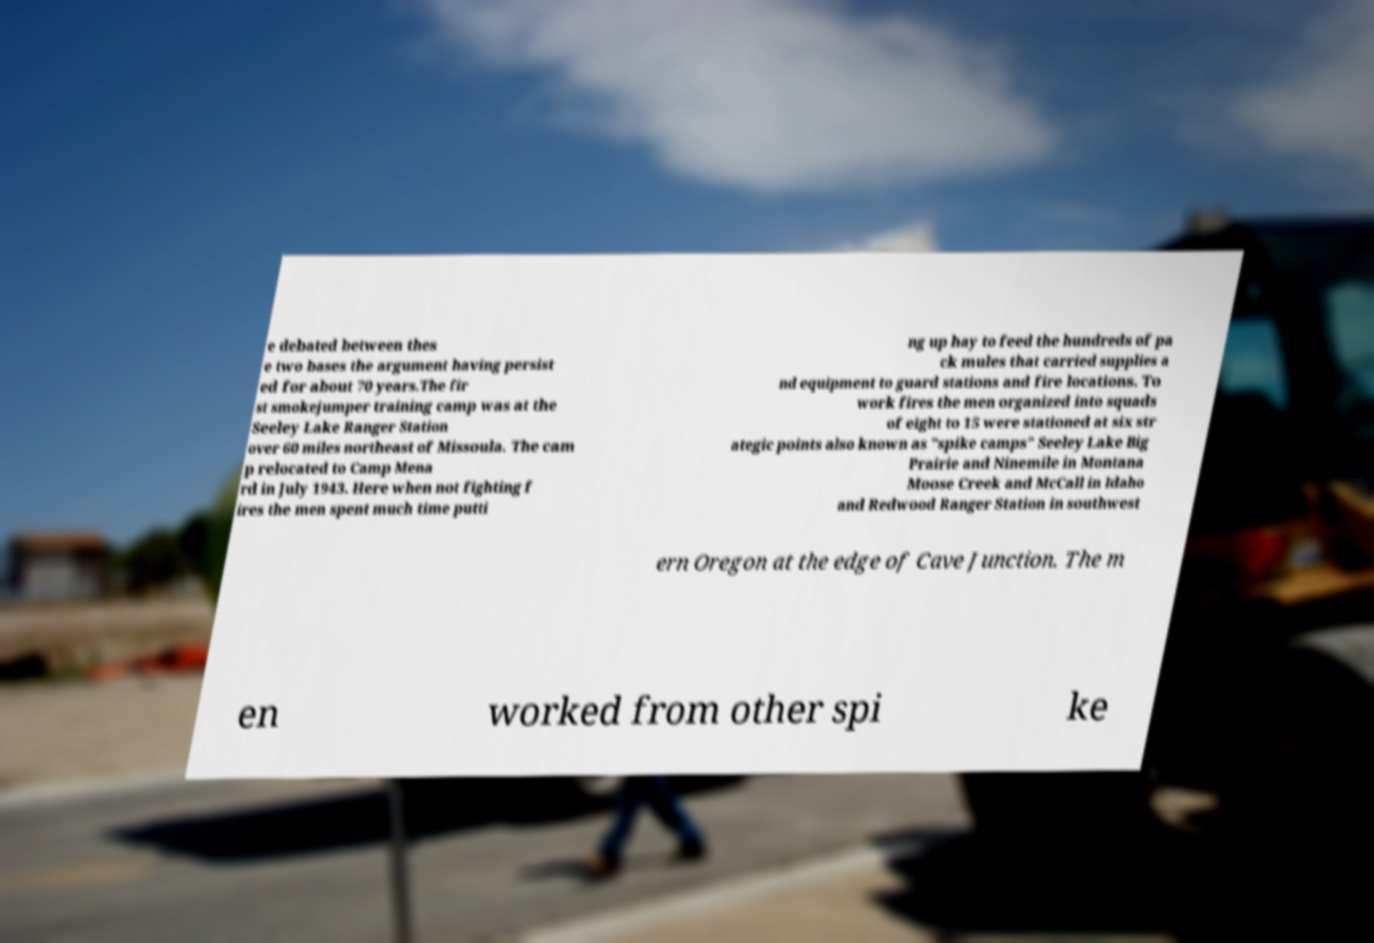What messages or text are displayed in this image? I need them in a readable, typed format. e debated between thes e two bases the argument having persist ed for about 70 years.The fir st smokejumper training camp was at the Seeley Lake Ranger Station over 60 miles northeast of Missoula. The cam p relocated to Camp Mena rd in July 1943. Here when not fighting f ires the men spent much time putti ng up hay to feed the hundreds of pa ck mules that carried supplies a nd equipment to guard stations and fire locations. To work fires the men organized into squads of eight to 15 were stationed at six str ategic points also known as "spike camps" Seeley Lake Big Prairie and Ninemile in Montana Moose Creek and McCall in Idaho and Redwood Ranger Station in southwest ern Oregon at the edge of Cave Junction. The m en worked from other spi ke 